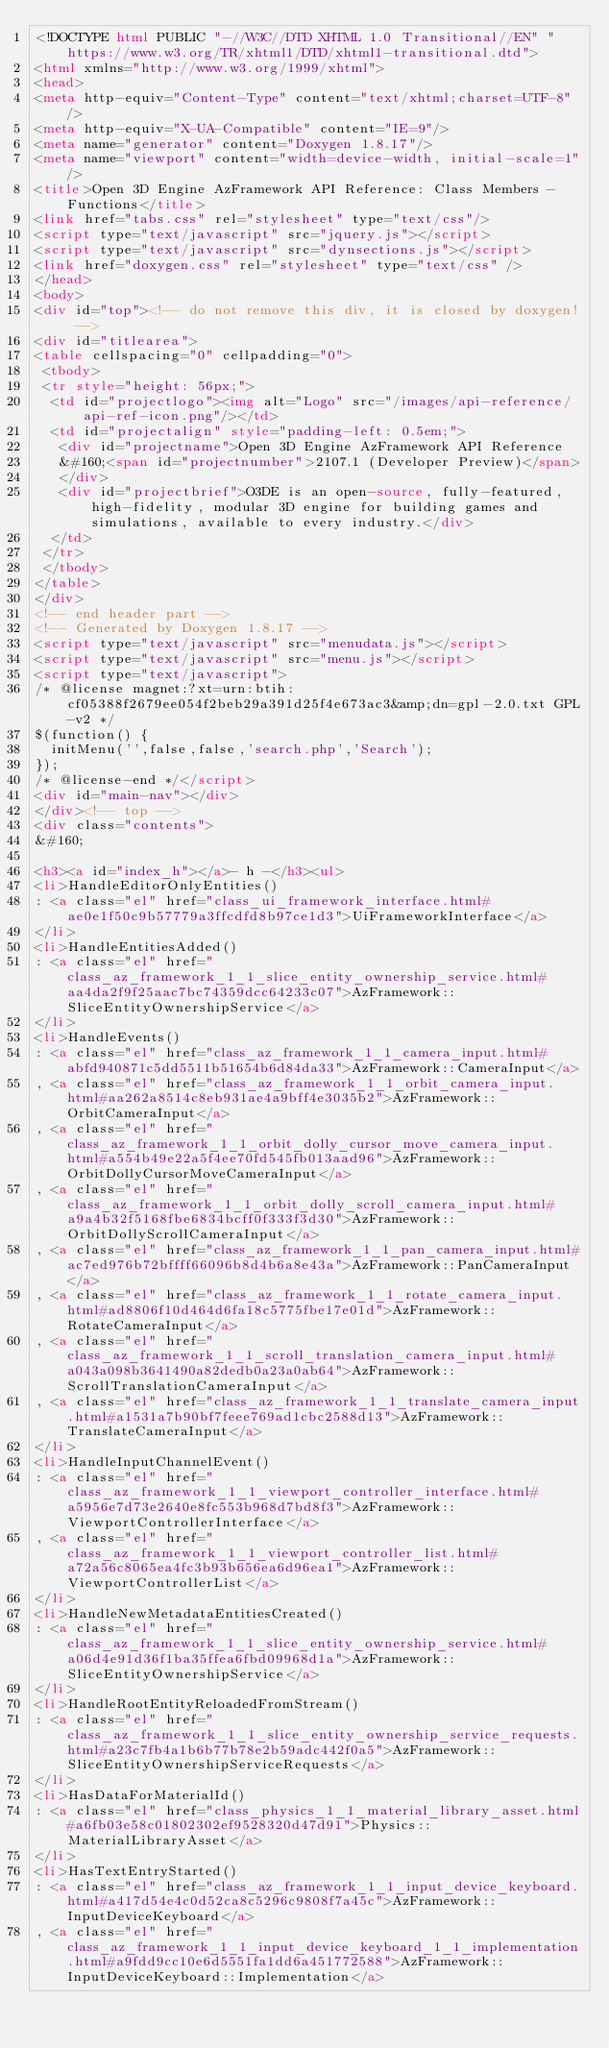Convert code to text. <code><loc_0><loc_0><loc_500><loc_500><_HTML_><!DOCTYPE html PUBLIC "-//W3C//DTD XHTML 1.0 Transitional//EN" "https://www.w3.org/TR/xhtml1/DTD/xhtml1-transitional.dtd">
<html xmlns="http://www.w3.org/1999/xhtml">
<head>
<meta http-equiv="Content-Type" content="text/xhtml;charset=UTF-8"/>
<meta http-equiv="X-UA-Compatible" content="IE=9"/>
<meta name="generator" content="Doxygen 1.8.17"/>
<meta name="viewport" content="width=device-width, initial-scale=1"/>
<title>Open 3D Engine AzFramework API Reference: Class Members - Functions</title>
<link href="tabs.css" rel="stylesheet" type="text/css"/>
<script type="text/javascript" src="jquery.js"></script>
<script type="text/javascript" src="dynsections.js"></script>
<link href="doxygen.css" rel="stylesheet" type="text/css" />
</head>
<body>
<div id="top"><!-- do not remove this div, it is closed by doxygen! -->
<div id="titlearea">
<table cellspacing="0" cellpadding="0">
 <tbody>
 <tr style="height: 56px;">
  <td id="projectlogo"><img alt="Logo" src="/images/api-reference/api-ref-icon.png"/></td>
  <td id="projectalign" style="padding-left: 0.5em;">
   <div id="projectname">Open 3D Engine AzFramework API Reference
   &#160;<span id="projectnumber">2107.1 (Developer Preview)</span>
   </div>
   <div id="projectbrief">O3DE is an open-source, fully-featured, high-fidelity, modular 3D engine for building games and simulations, available to every industry.</div>
  </td>
 </tr>
 </tbody>
</table>
</div>
<!-- end header part -->
<!-- Generated by Doxygen 1.8.17 -->
<script type="text/javascript" src="menudata.js"></script>
<script type="text/javascript" src="menu.js"></script>
<script type="text/javascript">
/* @license magnet:?xt=urn:btih:cf05388f2679ee054f2beb29a391d25f4e673ac3&amp;dn=gpl-2.0.txt GPL-v2 */
$(function() {
  initMenu('',false,false,'search.php','Search');
});
/* @license-end */</script>
<div id="main-nav"></div>
</div><!-- top -->
<div class="contents">
&#160;

<h3><a id="index_h"></a>- h -</h3><ul>
<li>HandleEditorOnlyEntities()
: <a class="el" href="class_ui_framework_interface.html#ae0e1f50c9b57779a3ffcdfd8b97ce1d3">UiFrameworkInterface</a>
</li>
<li>HandleEntitiesAdded()
: <a class="el" href="class_az_framework_1_1_slice_entity_ownership_service.html#aa4da2f9f25aac7bc74359dcc64233c07">AzFramework::SliceEntityOwnershipService</a>
</li>
<li>HandleEvents()
: <a class="el" href="class_az_framework_1_1_camera_input.html#abfd940871c5dd5511b51654b6d84da33">AzFramework::CameraInput</a>
, <a class="el" href="class_az_framework_1_1_orbit_camera_input.html#aa262a8514c8eb931ae4a9bff4e3035b2">AzFramework::OrbitCameraInput</a>
, <a class="el" href="class_az_framework_1_1_orbit_dolly_cursor_move_camera_input.html#a554b49e22a5f4ee70fd545fb013aad96">AzFramework::OrbitDollyCursorMoveCameraInput</a>
, <a class="el" href="class_az_framework_1_1_orbit_dolly_scroll_camera_input.html#a9a4b32f5168fbe6834bcff0f333f3d30">AzFramework::OrbitDollyScrollCameraInput</a>
, <a class="el" href="class_az_framework_1_1_pan_camera_input.html#ac7ed976b72bffff66096b8d4b6a8e43a">AzFramework::PanCameraInput</a>
, <a class="el" href="class_az_framework_1_1_rotate_camera_input.html#ad8806f10d464d6fa18c5775fbe17e01d">AzFramework::RotateCameraInput</a>
, <a class="el" href="class_az_framework_1_1_scroll_translation_camera_input.html#a043a098b3641490a82dedb0a23a0ab64">AzFramework::ScrollTranslationCameraInput</a>
, <a class="el" href="class_az_framework_1_1_translate_camera_input.html#a1531a7b90bf7feee769ad1cbc2588d13">AzFramework::TranslateCameraInput</a>
</li>
<li>HandleInputChannelEvent()
: <a class="el" href="class_az_framework_1_1_viewport_controller_interface.html#a5956e7d73e2640e8fc553b968d7bd8f3">AzFramework::ViewportControllerInterface</a>
, <a class="el" href="class_az_framework_1_1_viewport_controller_list.html#a72a56c8065ea4fc3b93b656ea6d96ea1">AzFramework::ViewportControllerList</a>
</li>
<li>HandleNewMetadataEntitiesCreated()
: <a class="el" href="class_az_framework_1_1_slice_entity_ownership_service.html#a06d4e91d36f1ba35ffea6fbd09968d1a">AzFramework::SliceEntityOwnershipService</a>
</li>
<li>HandleRootEntityReloadedFromStream()
: <a class="el" href="class_az_framework_1_1_slice_entity_ownership_service_requests.html#a23c7fb4a1b6b77b78e2b59adc442f0a5">AzFramework::SliceEntityOwnershipServiceRequests</a>
</li>
<li>HasDataForMaterialId()
: <a class="el" href="class_physics_1_1_material_library_asset.html#a6fb03e58c01802302ef9528320d47d91">Physics::MaterialLibraryAsset</a>
</li>
<li>HasTextEntryStarted()
: <a class="el" href="class_az_framework_1_1_input_device_keyboard.html#a417d54e4c0d52ca8c5296c9808f7a45c">AzFramework::InputDeviceKeyboard</a>
, <a class="el" href="class_az_framework_1_1_input_device_keyboard_1_1_implementation.html#a9fdd9cc10e6d5551fa1dd6a451772588">AzFramework::InputDeviceKeyboard::Implementation</a></code> 